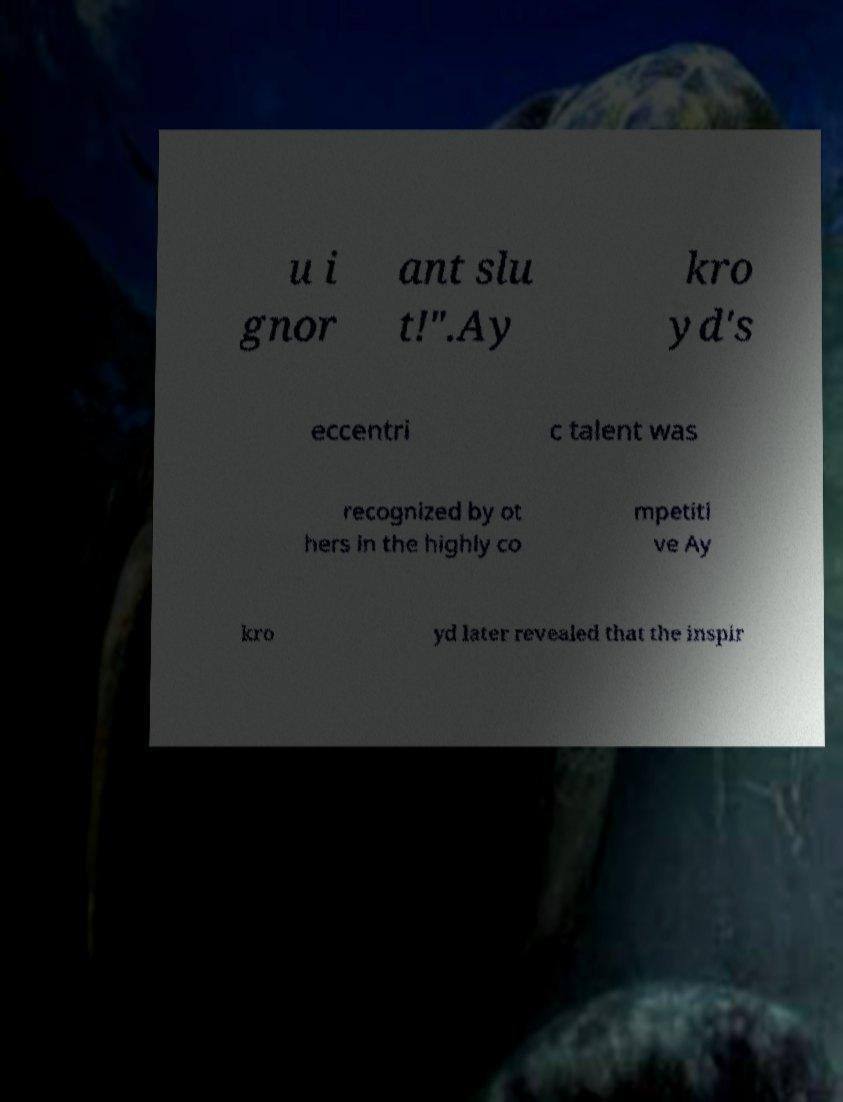What messages or text are displayed in this image? I need them in a readable, typed format. u i gnor ant slu t!".Ay kro yd's eccentri c talent was recognized by ot hers in the highly co mpetiti ve Ay kro yd later revealed that the inspir 